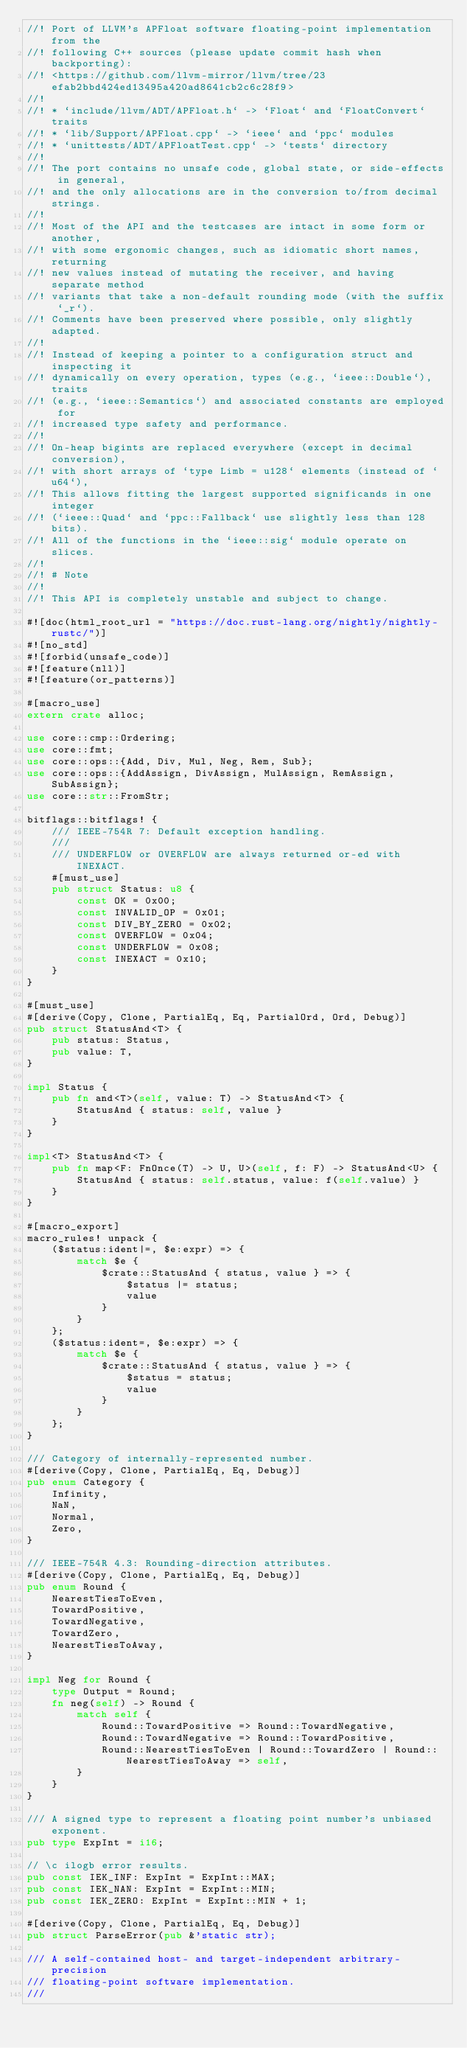Convert code to text. <code><loc_0><loc_0><loc_500><loc_500><_Rust_>//! Port of LLVM's APFloat software floating-point implementation from the
//! following C++ sources (please update commit hash when backporting):
//! <https://github.com/llvm-mirror/llvm/tree/23efab2bbd424ed13495a420ad8641cb2c6c28f9>
//!
//! * `include/llvm/ADT/APFloat.h` -> `Float` and `FloatConvert` traits
//! * `lib/Support/APFloat.cpp` -> `ieee` and `ppc` modules
//! * `unittests/ADT/APFloatTest.cpp` -> `tests` directory
//!
//! The port contains no unsafe code, global state, or side-effects in general,
//! and the only allocations are in the conversion to/from decimal strings.
//!
//! Most of the API and the testcases are intact in some form or another,
//! with some ergonomic changes, such as idiomatic short names, returning
//! new values instead of mutating the receiver, and having separate method
//! variants that take a non-default rounding mode (with the suffix `_r`).
//! Comments have been preserved where possible, only slightly adapted.
//!
//! Instead of keeping a pointer to a configuration struct and inspecting it
//! dynamically on every operation, types (e.g., `ieee::Double`), traits
//! (e.g., `ieee::Semantics`) and associated constants are employed for
//! increased type safety and performance.
//!
//! On-heap bigints are replaced everywhere (except in decimal conversion),
//! with short arrays of `type Limb = u128` elements (instead of `u64`),
//! This allows fitting the largest supported significands in one integer
//! (`ieee::Quad` and `ppc::Fallback` use slightly less than 128 bits).
//! All of the functions in the `ieee::sig` module operate on slices.
//!
//! # Note
//!
//! This API is completely unstable and subject to change.

#![doc(html_root_url = "https://doc.rust-lang.org/nightly/nightly-rustc/")]
#![no_std]
#![forbid(unsafe_code)]
#![feature(nll)]
#![feature(or_patterns)]

#[macro_use]
extern crate alloc;

use core::cmp::Ordering;
use core::fmt;
use core::ops::{Add, Div, Mul, Neg, Rem, Sub};
use core::ops::{AddAssign, DivAssign, MulAssign, RemAssign, SubAssign};
use core::str::FromStr;

bitflags::bitflags! {
    /// IEEE-754R 7: Default exception handling.
    ///
    /// UNDERFLOW or OVERFLOW are always returned or-ed with INEXACT.
    #[must_use]
    pub struct Status: u8 {
        const OK = 0x00;
        const INVALID_OP = 0x01;
        const DIV_BY_ZERO = 0x02;
        const OVERFLOW = 0x04;
        const UNDERFLOW = 0x08;
        const INEXACT = 0x10;
    }
}

#[must_use]
#[derive(Copy, Clone, PartialEq, Eq, PartialOrd, Ord, Debug)]
pub struct StatusAnd<T> {
    pub status: Status,
    pub value: T,
}

impl Status {
    pub fn and<T>(self, value: T) -> StatusAnd<T> {
        StatusAnd { status: self, value }
    }
}

impl<T> StatusAnd<T> {
    pub fn map<F: FnOnce(T) -> U, U>(self, f: F) -> StatusAnd<U> {
        StatusAnd { status: self.status, value: f(self.value) }
    }
}

#[macro_export]
macro_rules! unpack {
    ($status:ident|=, $e:expr) => {
        match $e {
            $crate::StatusAnd { status, value } => {
                $status |= status;
                value
            }
        }
    };
    ($status:ident=, $e:expr) => {
        match $e {
            $crate::StatusAnd { status, value } => {
                $status = status;
                value
            }
        }
    };
}

/// Category of internally-represented number.
#[derive(Copy, Clone, PartialEq, Eq, Debug)]
pub enum Category {
    Infinity,
    NaN,
    Normal,
    Zero,
}

/// IEEE-754R 4.3: Rounding-direction attributes.
#[derive(Copy, Clone, PartialEq, Eq, Debug)]
pub enum Round {
    NearestTiesToEven,
    TowardPositive,
    TowardNegative,
    TowardZero,
    NearestTiesToAway,
}

impl Neg for Round {
    type Output = Round;
    fn neg(self) -> Round {
        match self {
            Round::TowardPositive => Round::TowardNegative,
            Round::TowardNegative => Round::TowardPositive,
            Round::NearestTiesToEven | Round::TowardZero | Round::NearestTiesToAway => self,
        }
    }
}

/// A signed type to represent a floating point number's unbiased exponent.
pub type ExpInt = i16;

// \c ilogb error results.
pub const IEK_INF: ExpInt = ExpInt::MAX;
pub const IEK_NAN: ExpInt = ExpInt::MIN;
pub const IEK_ZERO: ExpInt = ExpInt::MIN + 1;

#[derive(Copy, Clone, PartialEq, Eq, Debug)]
pub struct ParseError(pub &'static str);

/// A self-contained host- and target-independent arbitrary-precision
/// floating-point software implementation.
///</code> 